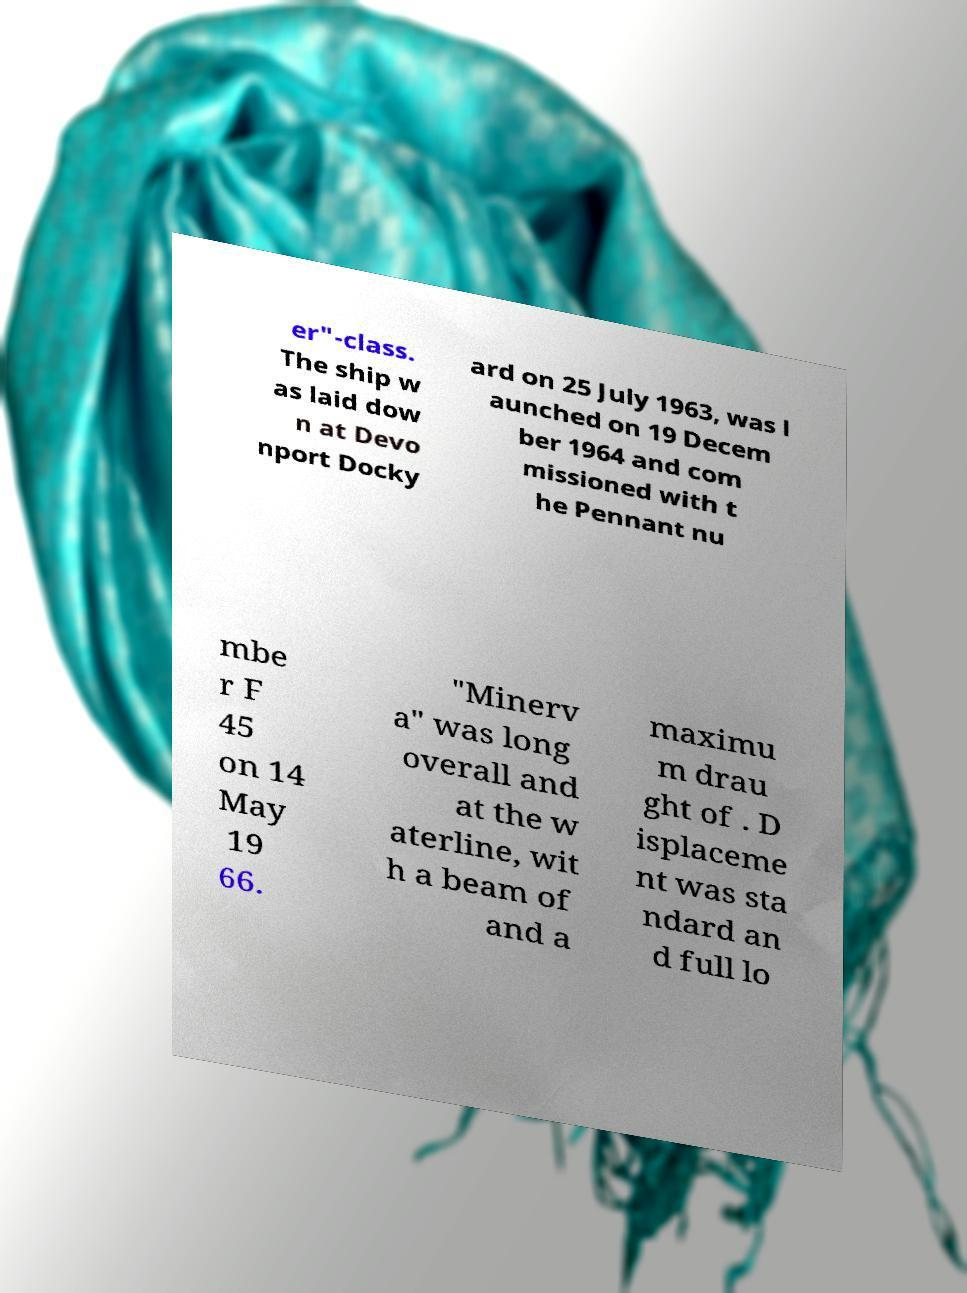There's text embedded in this image that I need extracted. Can you transcribe it verbatim? er"-class. The ship w as laid dow n at Devo nport Docky ard on 25 July 1963, was l aunched on 19 Decem ber 1964 and com missioned with t he Pennant nu mbe r F 45 on 14 May 19 66. "Minerv a" was long overall and at the w aterline, wit h a beam of and a maximu m drau ght of . D isplaceme nt was sta ndard an d full lo 